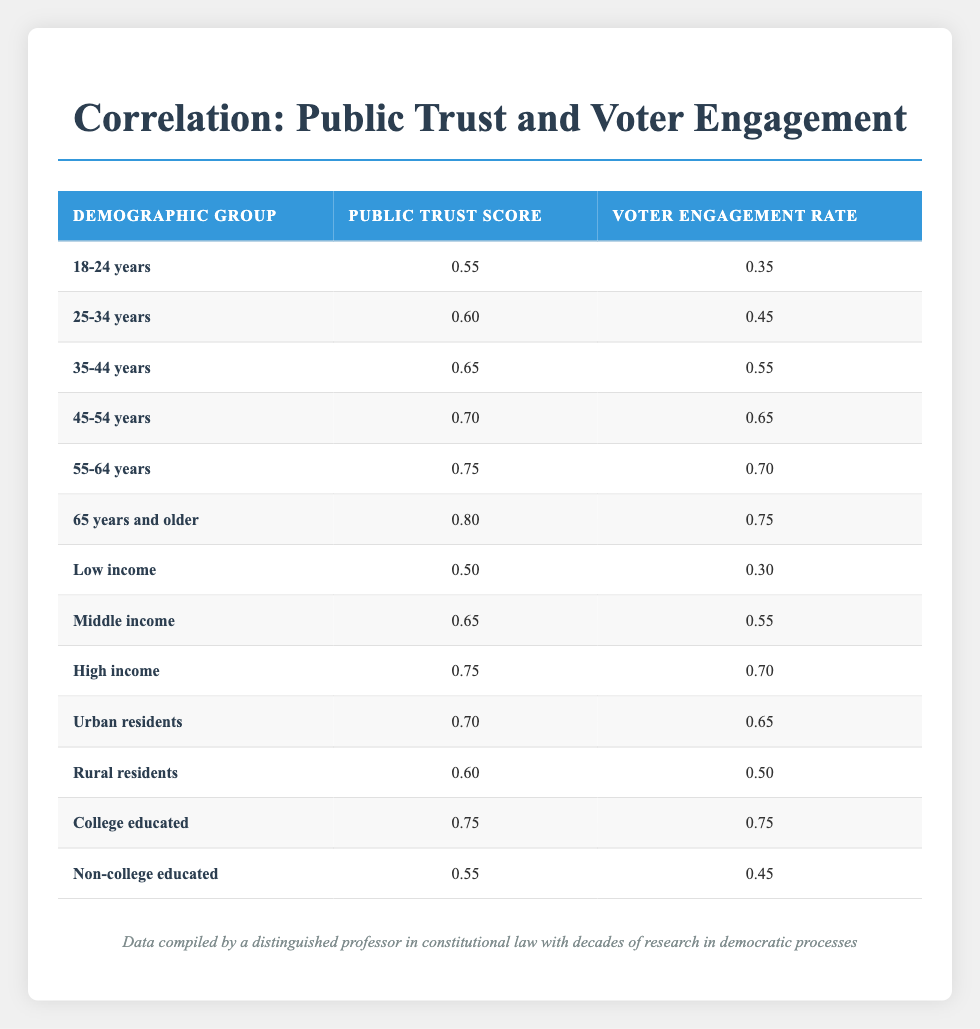What is the public trust score for the demographic group aged 65 years and older? The table indicates that the public trust score for the demographic group aged 65 years and older is 0.80, as listed in the corresponding row.
Answer: 0.80 What is the voter engagement rate for the 45-54 years demographic group? According to the table, the voter engagement rate for the 45-54 years demographic group is 0.65, as shown in the respective row.
Answer: 0.65 Which demographic group has the lowest public trust score? The data shows that the "Low income" group has the lowest public trust score of 0.50, as clearly presented in the table.
Answer: Low income What is the average public trust score across all demographic groups? To calculate the average, sum the public trust scores: (0.55 + 0.60 + 0.65 + 0.70 + 0.75 + 0.80 + 0.50 + 0.65 + 0.75 + 0.70 + 0.60 + 0.75 + 0.55) = 8.25. Then, divide by the number of groups (13), resulting in an average public trust score of 8.25 / 13 = 0.6346, which rounds to 0.63.
Answer: 0.63 Is the voter engagement rate for urban residents higher than that for rural residents? The voter engagement rate for urban residents is 0.65, while that for rural residents is 0.50. Since 0.65 is greater than 0.50, the statement is true based on the data presented.
Answer: Yes What is the difference in voter engagement rates between the college-educated group and the low-income group? The voter engagement rate for the college-educated group is 0.75 and for the low-income group is 0.30. To find the difference, subtract: 0.75 - 0.30 = 0.45.
Answer: 0.45 Does the data show that all income groups have a higher public trust score as income increases? To validate this, compare each income group's public trust scores: Low income (0.50), Middle income (0.65), and High income (0.75). The scores increase consistently as income increases, confirming that the statement is true.
Answer: Yes What is the public trust score for non-college educated individuals, and how does it compare to that for the 25-34 years age group? The public trust score for non-college educated individuals is 0.55, while for the 25-34 years age group, it is 0.60. Comparing these, 0.60 is higher than 0.55, which indicates that the age group's score is better.
Answer: 0.55 and lower Identify the demographic group with the highest voter engagement rate. The table indicates that the demographic group 65 years and older has the highest voter engagement rate at 0.75, clearly listed in the respective row.
Answer: 65 years and older 